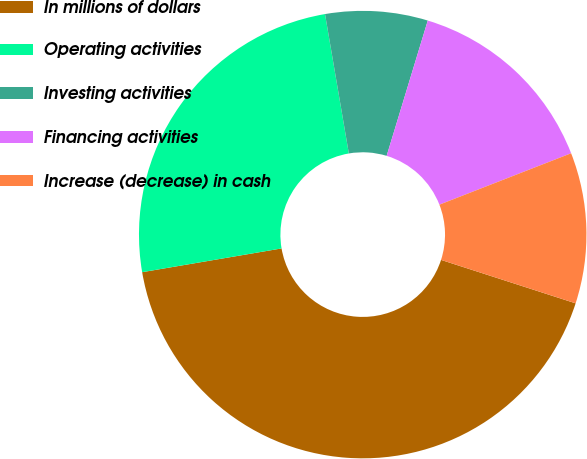<chart> <loc_0><loc_0><loc_500><loc_500><pie_chart><fcel>In millions of dollars<fcel>Operating activities<fcel>Investing activities<fcel>Financing activities<fcel>Increase (decrease) in cash<nl><fcel>42.34%<fcel>24.99%<fcel>7.39%<fcel>14.38%<fcel>10.89%<nl></chart> 